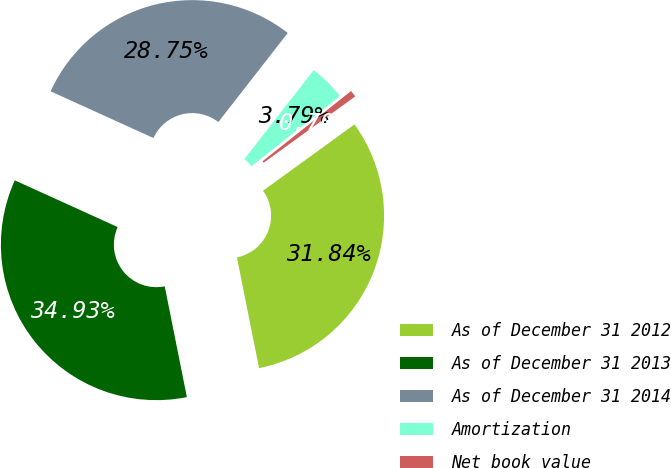Convert chart to OTSL. <chart><loc_0><loc_0><loc_500><loc_500><pie_chart><fcel>As of December 31 2012<fcel>As of December 31 2013<fcel>As of December 31 2014<fcel>Amortization<fcel>Net book value<nl><fcel>31.84%<fcel>34.93%<fcel>28.75%<fcel>3.79%<fcel>0.7%<nl></chart> 